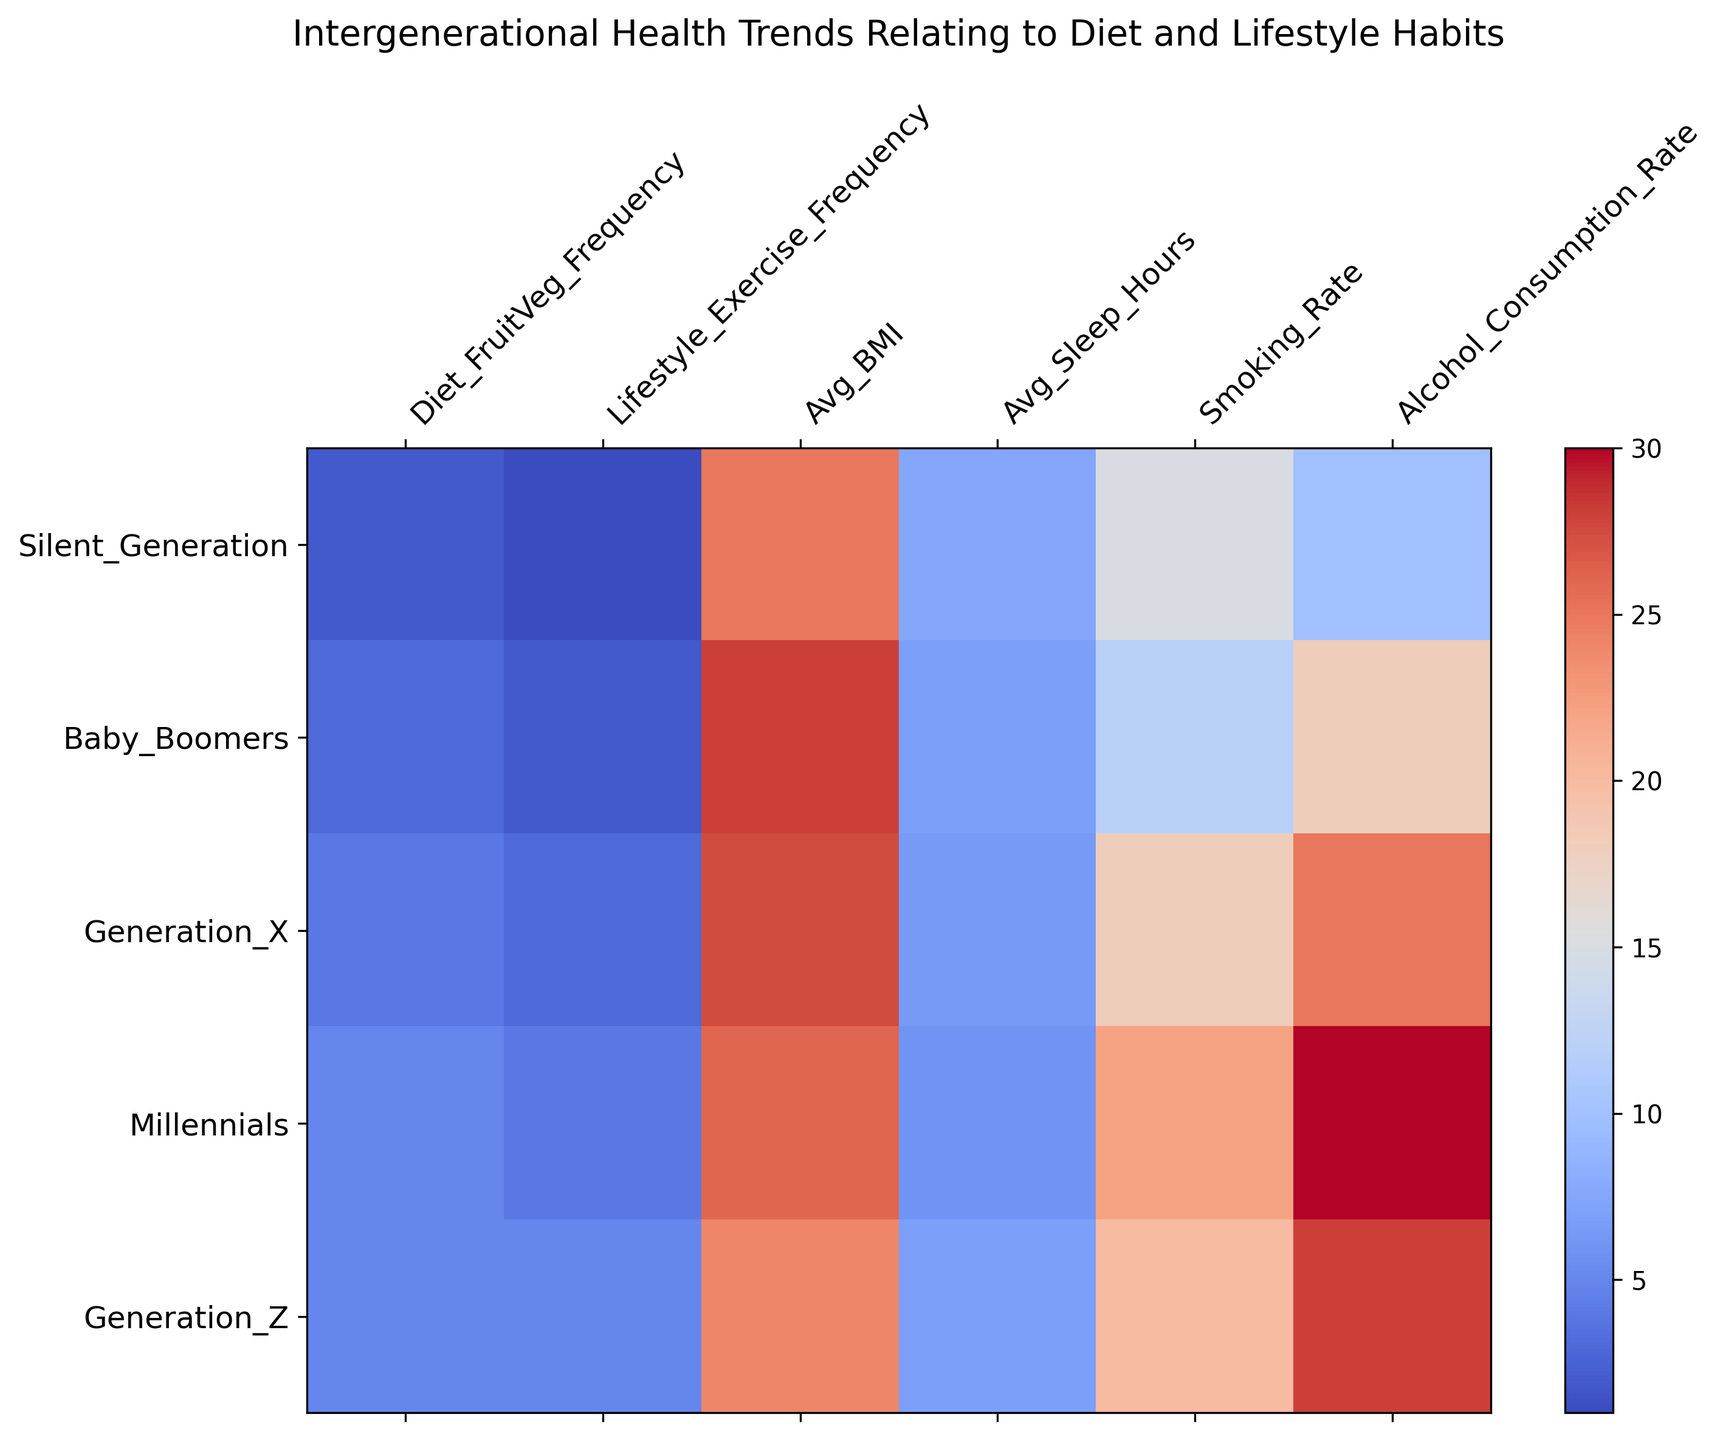What's the average BMI value for Baby Boomers and Generation X? Look at the Avg_BMI values for Baby Boomers and Generation X. Sum these values (28 + 27.5) and divide by 2 to get the average.
Answer: (28 + 27.5)/2 = 27.75 Which generation has the highest fruit and vegetable intake frequency? Observe the Diet_FruitVeg_Frequency column and find the highest value. The highest value is 5, which corresponds to Millennials and Generation Z.
Answer: Millennials, Generation Z How does the average sleep hours compare between Millennials and Baby Boomers? Look at the Avg_Sleep_Hours for both Millennials and Baby Boomers. Compare the values: Millennials have 6 hours, while Baby Boomers have 7 hours.
Answer: Baby Boomers sleep 1 hour more on average than Millennials What is the difference in smoking rates between the Silent Generation and Generation Z? Compare the Smoking_Rate values for the Silent Generation and Generation Z. Subtract the Smoking_Rate of the Silent Generation (15) from Generation Z (20).
Answer: 20 - 15 = 5 Which generation has the lowest alcohol consumption rate? Look at the Alcohol_Consumption_Rate column and find the lowest value. The lowest value is 10, which corresponds to the Silent Generation.
Answer: Silent Generation What is the total exercise frequency for all generations combined? Sum the Lifestyle_Exercise_Frequency values across all generations: 1 + 2 + 3 + 4 + 5 = 15.
Answer: 15 How does the average BMI change from Baby Boomers to Millennials? Look at the Avg_BMI values for Baby Boomers and Millennials. The BMI decreases from 28 to 26. Subtract the Avg_BMI of Millennials from Baby Boomers to find the change: 28 - 26.
Answer: BMI decreases by 2 Which generation has the highest smoking rate and what is its value? Observe the Smoking_Rate column and find the highest value. The highest value is 22, which corresponds to Millennials.
Answer: Millennials, 22 What is the combined fruit and vegetable intake frequency for Generation X and Generation Z? Look at the Diet_FruitVeg_Frequency for Generation X and Generation Z. Sum these values: 4 + 5.
Answer: 4 + 5 = 9 